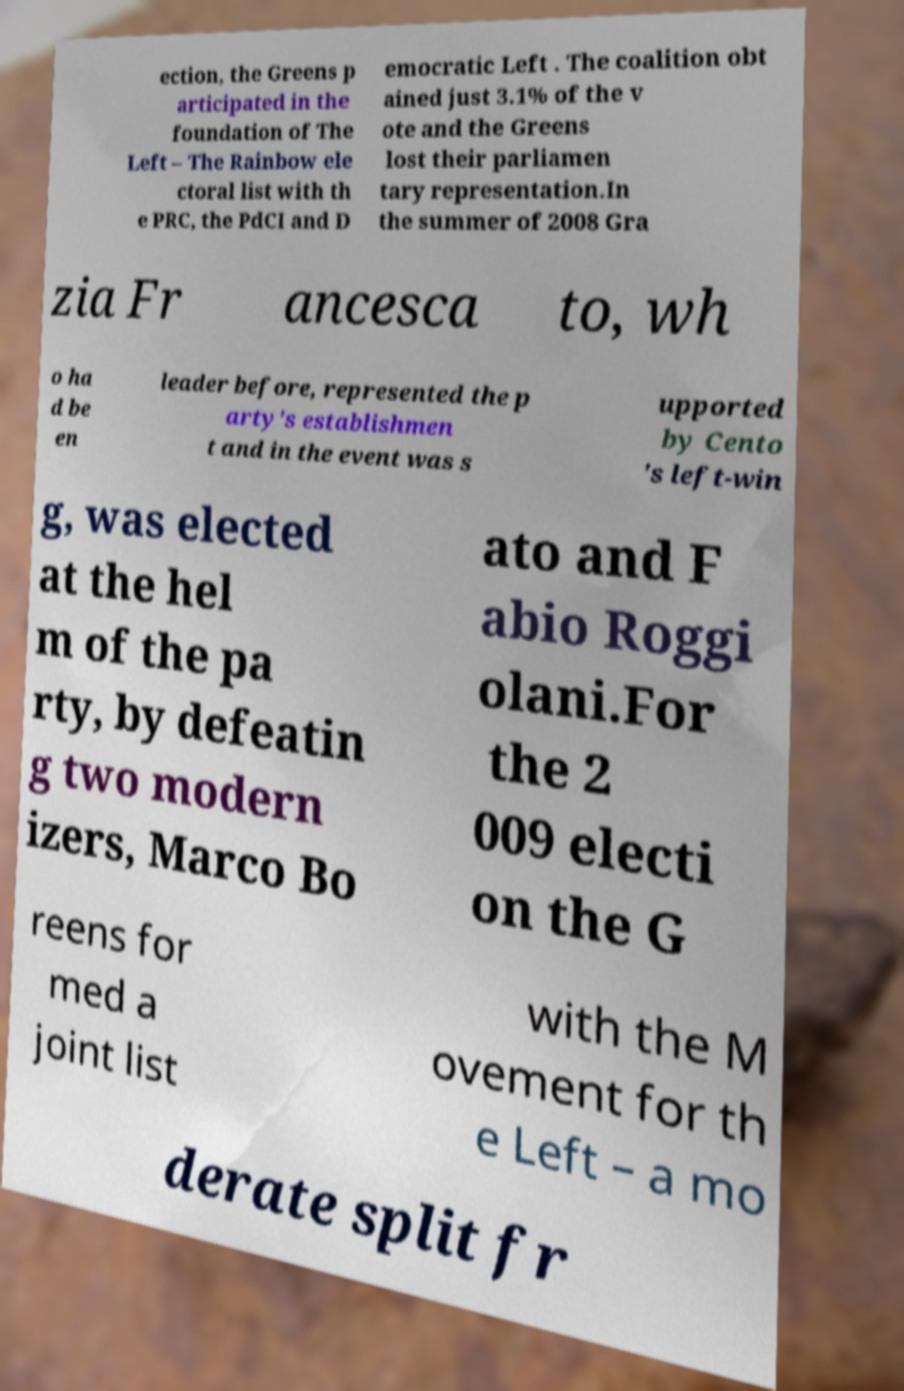There's text embedded in this image that I need extracted. Can you transcribe it verbatim? ection, the Greens p articipated in the foundation of The Left – The Rainbow ele ctoral list with th e PRC, the PdCI and D emocratic Left . The coalition obt ained just 3.1% of the v ote and the Greens lost their parliamen tary representation.In the summer of 2008 Gra zia Fr ancesca to, wh o ha d be en leader before, represented the p arty's establishmen t and in the event was s upported by Cento 's left-win g, was elected at the hel m of the pa rty, by defeatin g two modern izers, Marco Bo ato and F abio Roggi olani.For the 2 009 electi on the G reens for med a joint list with the M ovement for th e Left – a mo derate split fr 